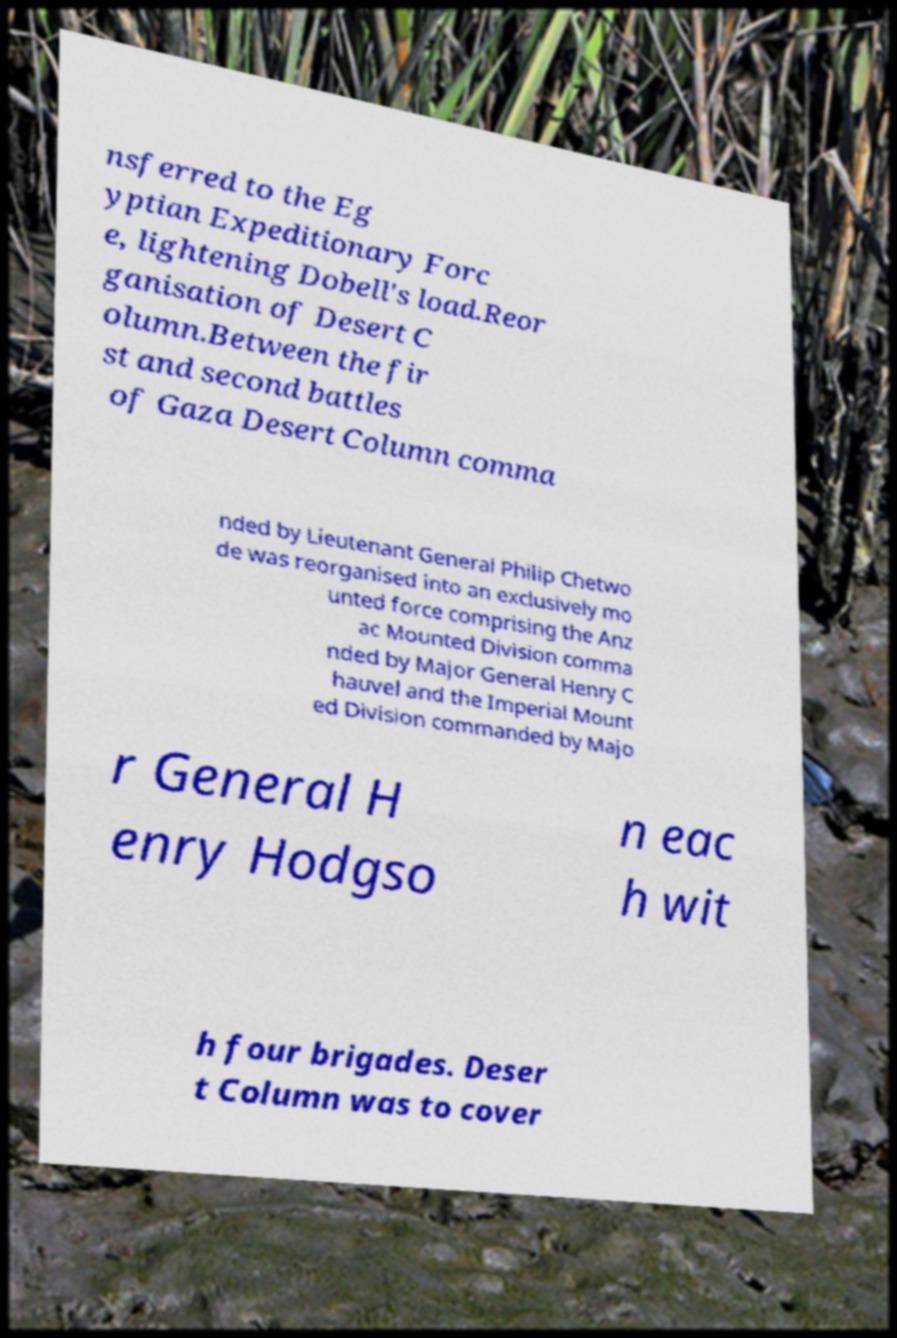Can you read and provide the text displayed in the image?This photo seems to have some interesting text. Can you extract and type it out for me? nsferred to the Eg yptian Expeditionary Forc e, lightening Dobell's load.Reor ganisation of Desert C olumn.Between the fir st and second battles of Gaza Desert Column comma nded by Lieutenant General Philip Chetwo de was reorganised into an exclusively mo unted force comprising the Anz ac Mounted Division comma nded by Major General Henry C hauvel and the Imperial Mount ed Division commanded by Majo r General H enry Hodgso n eac h wit h four brigades. Deser t Column was to cover 